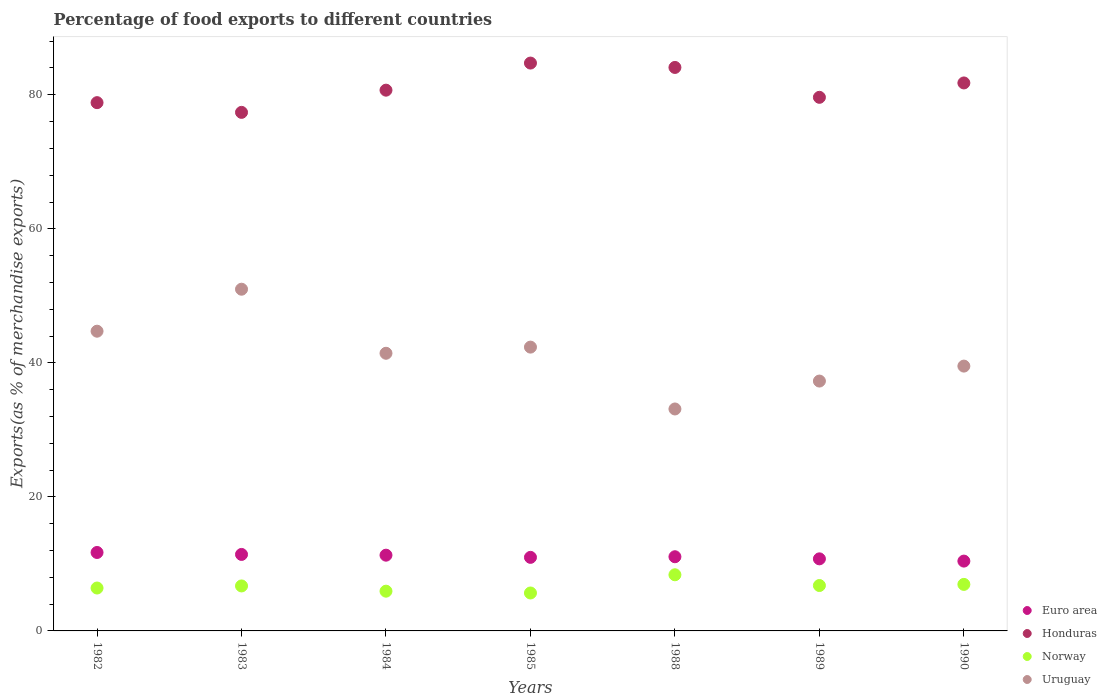What is the percentage of exports to different countries in Uruguay in 1990?
Provide a succinct answer. 39.52. Across all years, what is the maximum percentage of exports to different countries in Euro area?
Keep it short and to the point. 11.71. Across all years, what is the minimum percentage of exports to different countries in Norway?
Your answer should be very brief. 5.66. In which year was the percentage of exports to different countries in Euro area maximum?
Ensure brevity in your answer.  1982. In which year was the percentage of exports to different countries in Honduras minimum?
Your answer should be very brief. 1983. What is the total percentage of exports to different countries in Euro area in the graph?
Provide a succinct answer. 77.64. What is the difference between the percentage of exports to different countries in Uruguay in 1989 and that in 1990?
Offer a very short reply. -2.23. What is the difference between the percentage of exports to different countries in Norway in 1985 and the percentage of exports to different countries in Euro area in 1989?
Offer a terse response. -5.09. What is the average percentage of exports to different countries in Uruguay per year?
Your answer should be compact. 41.34. In the year 1988, what is the difference between the percentage of exports to different countries in Honduras and percentage of exports to different countries in Uruguay?
Ensure brevity in your answer.  50.96. In how many years, is the percentage of exports to different countries in Uruguay greater than 16 %?
Keep it short and to the point. 7. What is the ratio of the percentage of exports to different countries in Uruguay in 1985 to that in 1990?
Ensure brevity in your answer.  1.07. Is the percentage of exports to different countries in Uruguay in 1983 less than that in 1988?
Provide a succinct answer. No. What is the difference between the highest and the second highest percentage of exports to different countries in Euro area?
Give a very brief answer. 0.29. What is the difference between the highest and the lowest percentage of exports to different countries in Uruguay?
Make the answer very short. 17.87. Is the sum of the percentage of exports to different countries in Uruguay in 1988 and 1990 greater than the maximum percentage of exports to different countries in Honduras across all years?
Keep it short and to the point. No. Is it the case that in every year, the sum of the percentage of exports to different countries in Euro area and percentage of exports to different countries in Norway  is greater than the sum of percentage of exports to different countries in Honduras and percentage of exports to different countries in Uruguay?
Your answer should be very brief. No. Is it the case that in every year, the sum of the percentage of exports to different countries in Honduras and percentage of exports to different countries in Norway  is greater than the percentage of exports to different countries in Uruguay?
Your response must be concise. Yes. Does the graph contain grids?
Your answer should be compact. No. Where does the legend appear in the graph?
Your answer should be compact. Bottom right. How many legend labels are there?
Provide a short and direct response. 4. How are the legend labels stacked?
Provide a succinct answer. Vertical. What is the title of the graph?
Your answer should be compact. Percentage of food exports to different countries. What is the label or title of the Y-axis?
Your answer should be compact. Exports(as % of merchandise exports). What is the Exports(as % of merchandise exports) in Euro area in 1982?
Offer a terse response. 11.71. What is the Exports(as % of merchandise exports) of Honduras in 1982?
Provide a short and direct response. 78.83. What is the Exports(as % of merchandise exports) of Norway in 1982?
Offer a terse response. 6.4. What is the Exports(as % of merchandise exports) of Uruguay in 1982?
Give a very brief answer. 44.72. What is the Exports(as % of merchandise exports) in Euro area in 1983?
Your response must be concise. 11.41. What is the Exports(as % of merchandise exports) in Honduras in 1983?
Your answer should be compact. 77.38. What is the Exports(as % of merchandise exports) in Norway in 1983?
Keep it short and to the point. 6.71. What is the Exports(as % of merchandise exports) of Uruguay in 1983?
Make the answer very short. 50.99. What is the Exports(as % of merchandise exports) of Euro area in 1984?
Offer a terse response. 11.3. What is the Exports(as % of merchandise exports) in Honduras in 1984?
Keep it short and to the point. 80.69. What is the Exports(as % of merchandise exports) of Norway in 1984?
Provide a succinct answer. 5.93. What is the Exports(as % of merchandise exports) of Uruguay in 1984?
Offer a very short reply. 41.43. What is the Exports(as % of merchandise exports) of Euro area in 1985?
Offer a very short reply. 10.98. What is the Exports(as % of merchandise exports) of Honduras in 1985?
Give a very brief answer. 84.73. What is the Exports(as % of merchandise exports) of Norway in 1985?
Keep it short and to the point. 5.66. What is the Exports(as % of merchandise exports) of Uruguay in 1985?
Your response must be concise. 42.35. What is the Exports(as % of merchandise exports) of Euro area in 1988?
Provide a short and direct response. 11.07. What is the Exports(as % of merchandise exports) of Honduras in 1988?
Provide a short and direct response. 84.08. What is the Exports(as % of merchandise exports) in Norway in 1988?
Keep it short and to the point. 8.38. What is the Exports(as % of merchandise exports) of Uruguay in 1988?
Ensure brevity in your answer.  33.12. What is the Exports(as % of merchandise exports) of Euro area in 1989?
Offer a terse response. 10.75. What is the Exports(as % of merchandise exports) of Honduras in 1989?
Offer a very short reply. 79.62. What is the Exports(as % of merchandise exports) of Norway in 1989?
Provide a short and direct response. 6.77. What is the Exports(as % of merchandise exports) in Uruguay in 1989?
Keep it short and to the point. 37.28. What is the Exports(as % of merchandise exports) in Euro area in 1990?
Your response must be concise. 10.42. What is the Exports(as % of merchandise exports) in Honduras in 1990?
Your answer should be compact. 81.77. What is the Exports(as % of merchandise exports) in Norway in 1990?
Provide a succinct answer. 6.94. What is the Exports(as % of merchandise exports) of Uruguay in 1990?
Give a very brief answer. 39.52. Across all years, what is the maximum Exports(as % of merchandise exports) of Euro area?
Give a very brief answer. 11.71. Across all years, what is the maximum Exports(as % of merchandise exports) of Honduras?
Your response must be concise. 84.73. Across all years, what is the maximum Exports(as % of merchandise exports) in Norway?
Your answer should be very brief. 8.38. Across all years, what is the maximum Exports(as % of merchandise exports) of Uruguay?
Your response must be concise. 50.99. Across all years, what is the minimum Exports(as % of merchandise exports) of Euro area?
Offer a very short reply. 10.42. Across all years, what is the minimum Exports(as % of merchandise exports) in Honduras?
Ensure brevity in your answer.  77.38. Across all years, what is the minimum Exports(as % of merchandise exports) of Norway?
Give a very brief answer. 5.66. Across all years, what is the minimum Exports(as % of merchandise exports) of Uruguay?
Your answer should be compact. 33.12. What is the total Exports(as % of merchandise exports) of Euro area in the graph?
Offer a terse response. 77.64. What is the total Exports(as % of merchandise exports) in Honduras in the graph?
Keep it short and to the point. 567.09. What is the total Exports(as % of merchandise exports) in Norway in the graph?
Provide a succinct answer. 46.8. What is the total Exports(as % of merchandise exports) in Uruguay in the graph?
Ensure brevity in your answer.  289.41. What is the difference between the Exports(as % of merchandise exports) of Euro area in 1982 and that in 1983?
Offer a terse response. 0.29. What is the difference between the Exports(as % of merchandise exports) in Honduras in 1982 and that in 1983?
Keep it short and to the point. 1.45. What is the difference between the Exports(as % of merchandise exports) of Norway in 1982 and that in 1983?
Ensure brevity in your answer.  -0.31. What is the difference between the Exports(as % of merchandise exports) in Uruguay in 1982 and that in 1983?
Offer a very short reply. -6.26. What is the difference between the Exports(as % of merchandise exports) of Euro area in 1982 and that in 1984?
Keep it short and to the point. 0.4. What is the difference between the Exports(as % of merchandise exports) in Honduras in 1982 and that in 1984?
Your answer should be compact. -1.86. What is the difference between the Exports(as % of merchandise exports) in Norway in 1982 and that in 1984?
Provide a short and direct response. 0.47. What is the difference between the Exports(as % of merchandise exports) of Uruguay in 1982 and that in 1984?
Keep it short and to the point. 3.29. What is the difference between the Exports(as % of merchandise exports) in Euro area in 1982 and that in 1985?
Your answer should be very brief. 0.73. What is the difference between the Exports(as % of merchandise exports) of Honduras in 1982 and that in 1985?
Your answer should be very brief. -5.91. What is the difference between the Exports(as % of merchandise exports) in Norway in 1982 and that in 1985?
Offer a very short reply. 0.74. What is the difference between the Exports(as % of merchandise exports) of Uruguay in 1982 and that in 1985?
Offer a terse response. 2.38. What is the difference between the Exports(as % of merchandise exports) of Euro area in 1982 and that in 1988?
Provide a short and direct response. 0.64. What is the difference between the Exports(as % of merchandise exports) of Honduras in 1982 and that in 1988?
Your answer should be very brief. -5.25. What is the difference between the Exports(as % of merchandise exports) in Norway in 1982 and that in 1988?
Your response must be concise. -1.98. What is the difference between the Exports(as % of merchandise exports) in Uruguay in 1982 and that in 1988?
Provide a short and direct response. 11.6. What is the difference between the Exports(as % of merchandise exports) in Euro area in 1982 and that in 1989?
Your answer should be compact. 0.95. What is the difference between the Exports(as % of merchandise exports) in Honduras in 1982 and that in 1989?
Your answer should be very brief. -0.8. What is the difference between the Exports(as % of merchandise exports) of Norway in 1982 and that in 1989?
Offer a terse response. -0.37. What is the difference between the Exports(as % of merchandise exports) in Uruguay in 1982 and that in 1989?
Ensure brevity in your answer.  7.44. What is the difference between the Exports(as % of merchandise exports) of Euro area in 1982 and that in 1990?
Keep it short and to the point. 1.29. What is the difference between the Exports(as % of merchandise exports) in Honduras in 1982 and that in 1990?
Make the answer very short. -2.94. What is the difference between the Exports(as % of merchandise exports) of Norway in 1982 and that in 1990?
Offer a terse response. -0.54. What is the difference between the Exports(as % of merchandise exports) of Uruguay in 1982 and that in 1990?
Provide a succinct answer. 5.21. What is the difference between the Exports(as % of merchandise exports) of Euro area in 1983 and that in 1984?
Offer a very short reply. 0.11. What is the difference between the Exports(as % of merchandise exports) of Honduras in 1983 and that in 1984?
Give a very brief answer. -3.31. What is the difference between the Exports(as % of merchandise exports) in Norway in 1983 and that in 1984?
Provide a short and direct response. 0.78. What is the difference between the Exports(as % of merchandise exports) in Uruguay in 1983 and that in 1984?
Offer a terse response. 9.56. What is the difference between the Exports(as % of merchandise exports) of Euro area in 1983 and that in 1985?
Provide a succinct answer. 0.44. What is the difference between the Exports(as % of merchandise exports) of Honduras in 1983 and that in 1985?
Ensure brevity in your answer.  -7.36. What is the difference between the Exports(as % of merchandise exports) of Norway in 1983 and that in 1985?
Provide a short and direct response. 1.05. What is the difference between the Exports(as % of merchandise exports) in Uruguay in 1983 and that in 1985?
Your response must be concise. 8.64. What is the difference between the Exports(as % of merchandise exports) of Euro area in 1983 and that in 1988?
Your response must be concise. 0.34. What is the difference between the Exports(as % of merchandise exports) in Honduras in 1983 and that in 1988?
Offer a very short reply. -6.7. What is the difference between the Exports(as % of merchandise exports) in Norway in 1983 and that in 1988?
Make the answer very short. -1.67. What is the difference between the Exports(as % of merchandise exports) of Uruguay in 1983 and that in 1988?
Your answer should be very brief. 17.87. What is the difference between the Exports(as % of merchandise exports) in Euro area in 1983 and that in 1989?
Give a very brief answer. 0.66. What is the difference between the Exports(as % of merchandise exports) in Honduras in 1983 and that in 1989?
Give a very brief answer. -2.25. What is the difference between the Exports(as % of merchandise exports) of Norway in 1983 and that in 1989?
Offer a very short reply. -0.06. What is the difference between the Exports(as % of merchandise exports) in Uruguay in 1983 and that in 1989?
Offer a terse response. 13.71. What is the difference between the Exports(as % of merchandise exports) of Honduras in 1983 and that in 1990?
Offer a very short reply. -4.39. What is the difference between the Exports(as % of merchandise exports) of Norway in 1983 and that in 1990?
Give a very brief answer. -0.23. What is the difference between the Exports(as % of merchandise exports) of Uruguay in 1983 and that in 1990?
Keep it short and to the point. 11.47. What is the difference between the Exports(as % of merchandise exports) of Euro area in 1984 and that in 1985?
Give a very brief answer. 0.33. What is the difference between the Exports(as % of merchandise exports) of Honduras in 1984 and that in 1985?
Make the answer very short. -4.04. What is the difference between the Exports(as % of merchandise exports) in Norway in 1984 and that in 1985?
Your answer should be compact. 0.27. What is the difference between the Exports(as % of merchandise exports) of Uruguay in 1984 and that in 1985?
Offer a very short reply. -0.92. What is the difference between the Exports(as % of merchandise exports) in Euro area in 1984 and that in 1988?
Make the answer very short. 0.23. What is the difference between the Exports(as % of merchandise exports) of Honduras in 1984 and that in 1988?
Provide a succinct answer. -3.39. What is the difference between the Exports(as % of merchandise exports) in Norway in 1984 and that in 1988?
Your answer should be very brief. -2.45. What is the difference between the Exports(as % of merchandise exports) in Uruguay in 1984 and that in 1988?
Make the answer very short. 8.31. What is the difference between the Exports(as % of merchandise exports) in Euro area in 1984 and that in 1989?
Offer a very short reply. 0.55. What is the difference between the Exports(as % of merchandise exports) of Honduras in 1984 and that in 1989?
Make the answer very short. 1.07. What is the difference between the Exports(as % of merchandise exports) of Norway in 1984 and that in 1989?
Your answer should be compact. -0.84. What is the difference between the Exports(as % of merchandise exports) of Uruguay in 1984 and that in 1989?
Your answer should be compact. 4.15. What is the difference between the Exports(as % of merchandise exports) in Euro area in 1984 and that in 1990?
Offer a very short reply. 0.88. What is the difference between the Exports(as % of merchandise exports) of Honduras in 1984 and that in 1990?
Provide a succinct answer. -1.08. What is the difference between the Exports(as % of merchandise exports) of Norway in 1984 and that in 1990?
Keep it short and to the point. -1.01. What is the difference between the Exports(as % of merchandise exports) of Uruguay in 1984 and that in 1990?
Keep it short and to the point. 1.91. What is the difference between the Exports(as % of merchandise exports) of Euro area in 1985 and that in 1988?
Your answer should be very brief. -0.09. What is the difference between the Exports(as % of merchandise exports) of Honduras in 1985 and that in 1988?
Offer a terse response. 0.65. What is the difference between the Exports(as % of merchandise exports) in Norway in 1985 and that in 1988?
Make the answer very short. -2.72. What is the difference between the Exports(as % of merchandise exports) in Uruguay in 1985 and that in 1988?
Offer a terse response. 9.23. What is the difference between the Exports(as % of merchandise exports) of Euro area in 1985 and that in 1989?
Make the answer very short. 0.22. What is the difference between the Exports(as % of merchandise exports) of Honduras in 1985 and that in 1989?
Your response must be concise. 5.11. What is the difference between the Exports(as % of merchandise exports) of Norway in 1985 and that in 1989?
Your answer should be compact. -1.11. What is the difference between the Exports(as % of merchandise exports) of Uruguay in 1985 and that in 1989?
Ensure brevity in your answer.  5.07. What is the difference between the Exports(as % of merchandise exports) in Euro area in 1985 and that in 1990?
Offer a terse response. 0.56. What is the difference between the Exports(as % of merchandise exports) of Honduras in 1985 and that in 1990?
Your answer should be very brief. 2.97. What is the difference between the Exports(as % of merchandise exports) in Norway in 1985 and that in 1990?
Your response must be concise. -1.28. What is the difference between the Exports(as % of merchandise exports) in Uruguay in 1985 and that in 1990?
Make the answer very short. 2.83. What is the difference between the Exports(as % of merchandise exports) of Euro area in 1988 and that in 1989?
Keep it short and to the point. 0.31. What is the difference between the Exports(as % of merchandise exports) of Honduras in 1988 and that in 1989?
Ensure brevity in your answer.  4.46. What is the difference between the Exports(as % of merchandise exports) of Norway in 1988 and that in 1989?
Your answer should be compact. 1.6. What is the difference between the Exports(as % of merchandise exports) in Uruguay in 1988 and that in 1989?
Your answer should be very brief. -4.16. What is the difference between the Exports(as % of merchandise exports) of Euro area in 1988 and that in 1990?
Offer a very short reply. 0.65. What is the difference between the Exports(as % of merchandise exports) of Honduras in 1988 and that in 1990?
Provide a short and direct response. 2.31. What is the difference between the Exports(as % of merchandise exports) of Norway in 1988 and that in 1990?
Give a very brief answer. 1.44. What is the difference between the Exports(as % of merchandise exports) in Uruguay in 1988 and that in 1990?
Ensure brevity in your answer.  -6.4. What is the difference between the Exports(as % of merchandise exports) of Euro area in 1989 and that in 1990?
Ensure brevity in your answer.  0.34. What is the difference between the Exports(as % of merchandise exports) of Honduras in 1989 and that in 1990?
Ensure brevity in your answer.  -2.15. What is the difference between the Exports(as % of merchandise exports) of Norway in 1989 and that in 1990?
Offer a terse response. -0.17. What is the difference between the Exports(as % of merchandise exports) in Uruguay in 1989 and that in 1990?
Provide a succinct answer. -2.23. What is the difference between the Exports(as % of merchandise exports) in Euro area in 1982 and the Exports(as % of merchandise exports) in Honduras in 1983?
Make the answer very short. -65.67. What is the difference between the Exports(as % of merchandise exports) of Euro area in 1982 and the Exports(as % of merchandise exports) of Norway in 1983?
Offer a very short reply. 4.99. What is the difference between the Exports(as % of merchandise exports) in Euro area in 1982 and the Exports(as % of merchandise exports) in Uruguay in 1983?
Ensure brevity in your answer.  -39.28. What is the difference between the Exports(as % of merchandise exports) of Honduras in 1982 and the Exports(as % of merchandise exports) of Norway in 1983?
Ensure brevity in your answer.  72.11. What is the difference between the Exports(as % of merchandise exports) of Honduras in 1982 and the Exports(as % of merchandise exports) of Uruguay in 1983?
Provide a succinct answer. 27.84. What is the difference between the Exports(as % of merchandise exports) in Norway in 1982 and the Exports(as % of merchandise exports) in Uruguay in 1983?
Your answer should be compact. -44.59. What is the difference between the Exports(as % of merchandise exports) in Euro area in 1982 and the Exports(as % of merchandise exports) in Honduras in 1984?
Offer a terse response. -68.98. What is the difference between the Exports(as % of merchandise exports) in Euro area in 1982 and the Exports(as % of merchandise exports) in Norway in 1984?
Give a very brief answer. 5.77. What is the difference between the Exports(as % of merchandise exports) of Euro area in 1982 and the Exports(as % of merchandise exports) of Uruguay in 1984?
Keep it short and to the point. -29.73. What is the difference between the Exports(as % of merchandise exports) of Honduras in 1982 and the Exports(as % of merchandise exports) of Norway in 1984?
Provide a succinct answer. 72.9. What is the difference between the Exports(as % of merchandise exports) of Honduras in 1982 and the Exports(as % of merchandise exports) of Uruguay in 1984?
Provide a succinct answer. 37.4. What is the difference between the Exports(as % of merchandise exports) of Norway in 1982 and the Exports(as % of merchandise exports) of Uruguay in 1984?
Your answer should be very brief. -35.03. What is the difference between the Exports(as % of merchandise exports) of Euro area in 1982 and the Exports(as % of merchandise exports) of Honduras in 1985?
Offer a terse response. -73.03. What is the difference between the Exports(as % of merchandise exports) in Euro area in 1982 and the Exports(as % of merchandise exports) in Norway in 1985?
Make the answer very short. 6.04. What is the difference between the Exports(as % of merchandise exports) of Euro area in 1982 and the Exports(as % of merchandise exports) of Uruguay in 1985?
Make the answer very short. -30.64. What is the difference between the Exports(as % of merchandise exports) of Honduras in 1982 and the Exports(as % of merchandise exports) of Norway in 1985?
Provide a short and direct response. 73.17. What is the difference between the Exports(as % of merchandise exports) in Honduras in 1982 and the Exports(as % of merchandise exports) in Uruguay in 1985?
Give a very brief answer. 36.48. What is the difference between the Exports(as % of merchandise exports) of Norway in 1982 and the Exports(as % of merchandise exports) of Uruguay in 1985?
Your answer should be very brief. -35.95. What is the difference between the Exports(as % of merchandise exports) of Euro area in 1982 and the Exports(as % of merchandise exports) of Honduras in 1988?
Your answer should be very brief. -72.37. What is the difference between the Exports(as % of merchandise exports) in Euro area in 1982 and the Exports(as % of merchandise exports) in Norway in 1988?
Your response must be concise. 3.33. What is the difference between the Exports(as % of merchandise exports) of Euro area in 1982 and the Exports(as % of merchandise exports) of Uruguay in 1988?
Ensure brevity in your answer.  -21.41. What is the difference between the Exports(as % of merchandise exports) in Honduras in 1982 and the Exports(as % of merchandise exports) in Norway in 1988?
Offer a very short reply. 70.45. What is the difference between the Exports(as % of merchandise exports) in Honduras in 1982 and the Exports(as % of merchandise exports) in Uruguay in 1988?
Offer a very short reply. 45.71. What is the difference between the Exports(as % of merchandise exports) of Norway in 1982 and the Exports(as % of merchandise exports) of Uruguay in 1988?
Keep it short and to the point. -26.72. What is the difference between the Exports(as % of merchandise exports) in Euro area in 1982 and the Exports(as % of merchandise exports) in Honduras in 1989?
Your answer should be very brief. -67.92. What is the difference between the Exports(as % of merchandise exports) in Euro area in 1982 and the Exports(as % of merchandise exports) in Norway in 1989?
Your answer should be very brief. 4.93. What is the difference between the Exports(as % of merchandise exports) of Euro area in 1982 and the Exports(as % of merchandise exports) of Uruguay in 1989?
Your answer should be very brief. -25.58. What is the difference between the Exports(as % of merchandise exports) of Honduras in 1982 and the Exports(as % of merchandise exports) of Norway in 1989?
Make the answer very short. 72.05. What is the difference between the Exports(as % of merchandise exports) in Honduras in 1982 and the Exports(as % of merchandise exports) in Uruguay in 1989?
Your response must be concise. 41.54. What is the difference between the Exports(as % of merchandise exports) of Norway in 1982 and the Exports(as % of merchandise exports) of Uruguay in 1989?
Your answer should be very brief. -30.88. What is the difference between the Exports(as % of merchandise exports) in Euro area in 1982 and the Exports(as % of merchandise exports) in Honduras in 1990?
Provide a succinct answer. -70.06. What is the difference between the Exports(as % of merchandise exports) in Euro area in 1982 and the Exports(as % of merchandise exports) in Norway in 1990?
Your response must be concise. 4.76. What is the difference between the Exports(as % of merchandise exports) of Euro area in 1982 and the Exports(as % of merchandise exports) of Uruguay in 1990?
Give a very brief answer. -27.81. What is the difference between the Exports(as % of merchandise exports) in Honduras in 1982 and the Exports(as % of merchandise exports) in Norway in 1990?
Give a very brief answer. 71.88. What is the difference between the Exports(as % of merchandise exports) of Honduras in 1982 and the Exports(as % of merchandise exports) of Uruguay in 1990?
Your answer should be very brief. 39.31. What is the difference between the Exports(as % of merchandise exports) in Norway in 1982 and the Exports(as % of merchandise exports) in Uruguay in 1990?
Your answer should be compact. -33.12. What is the difference between the Exports(as % of merchandise exports) of Euro area in 1983 and the Exports(as % of merchandise exports) of Honduras in 1984?
Make the answer very short. -69.28. What is the difference between the Exports(as % of merchandise exports) of Euro area in 1983 and the Exports(as % of merchandise exports) of Norway in 1984?
Offer a very short reply. 5.48. What is the difference between the Exports(as % of merchandise exports) of Euro area in 1983 and the Exports(as % of merchandise exports) of Uruguay in 1984?
Provide a succinct answer. -30.02. What is the difference between the Exports(as % of merchandise exports) of Honduras in 1983 and the Exports(as % of merchandise exports) of Norway in 1984?
Make the answer very short. 71.45. What is the difference between the Exports(as % of merchandise exports) in Honduras in 1983 and the Exports(as % of merchandise exports) in Uruguay in 1984?
Your answer should be very brief. 35.95. What is the difference between the Exports(as % of merchandise exports) in Norway in 1983 and the Exports(as % of merchandise exports) in Uruguay in 1984?
Your answer should be compact. -34.72. What is the difference between the Exports(as % of merchandise exports) of Euro area in 1983 and the Exports(as % of merchandise exports) of Honduras in 1985?
Ensure brevity in your answer.  -73.32. What is the difference between the Exports(as % of merchandise exports) of Euro area in 1983 and the Exports(as % of merchandise exports) of Norway in 1985?
Offer a very short reply. 5.75. What is the difference between the Exports(as % of merchandise exports) in Euro area in 1983 and the Exports(as % of merchandise exports) in Uruguay in 1985?
Your answer should be very brief. -30.93. What is the difference between the Exports(as % of merchandise exports) in Honduras in 1983 and the Exports(as % of merchandise exports) in Norway in 1985?
Provide a short and direct response. 71.72. What is the difference between the Exports(as % of merchandise exports) in Honduras in 1983 and the Exports(as % of merchandise exports) in Uruguay in 1985?
Offer a terse response. 35.03. What is the difference between the Exports(as % of merchandise exports) of Norway in 1983 and the Exports(as % of merchandise exports) of Uruguay in 1985?
Offer a terse response. -35.64. What is the difference between the Exports(as % of merchandise exports) of Euro area in 1983 and the Exports(as % of merchandise exports) of Honduras in 1988?
Provide a short and direct response. -72.67. What is the difference between the Exports(as % of merchandise exports) in Euro area in 1983 and the Exports(as % of merchandise exports) in Norway in 1988?
Your response must be concise. 3.04. What is the difference between the Exports(as % of merchandise exports) in Euro area in 1983 and the Exports(as % of merchandise exports) in Uruguay in 1988?
Provide a short and direct response. -21.71. What is the difference between the Exports(as % of merchandise exports) of Honduras in 1983 and the Exports(as % of merchandise exports) of Norway in 1988?
Offer a terse response. 69. What is the difference between the Exports(as % of merchandise exports) of Honduras in 1983 and the Exports(as % of merchandise exports) of Uruguay in 1988?
Your response must be concise. 44.26. What is the difference between the Exports(as % of merchandise exports) of Norway in 1983 and the Exports(as % of merchandise exports) of Uruguay in 1988?
Offer a terse response. -26.41. What is the difference between the Exports(as % of merchandise exports) of Euro area in 1983 and the Exports(as % of merchandise exports) of Honduras in 1989?
Offer a very short reply. -68.21. What is the difference between the Exports(as % of merchandise exports) in Euro area in 1983 and the Exports(as % of merchandise exports) in Norway in 1989?
Give a very brief answer. 4.64. What is the difference between the Exports(as % of merchandise exports) of Euro area in 1983 and the Exports(as % of merchandise exports) of Uruguay in 1989?
Offer a very short reply. -25.87. What is the difference between the Exports(as % of merchandise exports) of Honduras in 1983 and the Exports(as % of merchandise exports) of Norway in 1989?
Provide a short and direct response. 70.6. What is the difference between the Exports(as % of merchandise exports) of Honduras in 1983 and the Exports(as % of merchandise exports) of Uruguay in 1989?
Your answer should be very brief. 40.09. What is the difference between the Exports(as % of merchandise exports) of Norway in 1983 and the Exports(as % of merchandise exports) of Uruguay in 1989?
Offer a terse response. -30.57. What is the difference between the Exports(as % of merchandise exports) of Euro area in 1983 and the Exports(as % of merchandise exports) of Honduras in 1990?
Offer a terse response. -70.35. What is the difference between the Exports(as % of merchandise exports) of Euro area in 1983 and the Exports(as % of merchandise exports) of Norway in 1990?
Provide a short and direct response. 4.47. What is the difference between the Exports(as % of merchandise exports) in Euro area in 1983 and the Exports(as % of merchandise exports) in Uruguay in 1990?
Your answer should be very brief. -28.1. What is the difference between the Exports(as % of merchandise exports) in Honduras in 1983 and the Exports(as % of merchandise exports) in Norway in 1990?
Keep it short and to the point. 70.43. What is the difference between the Exports(as % of merchandise exports) in Honduras in 1983 and the Exports(as % of merchandise exports) in Uruguay in 1990?
Ensure brevity in your answer.  37.86. What is the difference between the Exports(as % of merchandise exports) of Norway in 1983 and the Exports(as % of merchandise exports) of Uruguay in 1990?
Ensure brevity in your answer.  -32.8. What is the difference between the Exports(as % of merchandise exports) in Euro area in 1984 and the Exports(as % of merchandise exports) in Honduras in 1985?
Your answer should be compact. -73.43. What is the difference between the Exports(as % of merchandise exports) of Euro area in 1984 and the Exports(as % of merchandise exports) of Norway in 1985?
Your answer should be compact. 5.64. What is the difference between the Exports(as % of merchandise exports) in Euro area in 1984 and the Exports(as % of merchandise exports) in Uruguay in 1985?
Your answer should be very brief. -31.05. What is the difference between the Exports(as % of merchandise exports) in Honduras in 1984 and the Exports(as % of merchandise exports) in Norway in 1985?
Provide a succinct answer. 75.03. What is the difference between the Exports(as % of merchandise exports) of Honduras in 1984 and the Exports(as % of merchandise exports) of Uruguay in 1985?
Make the answer very short. 38.34. What is the difference between the Exports(as % of merchandise exports) of Norway in 1984 and the Exports(as % of merchandise exports) of Uruguay in 1985?
Make the answer very short. -36.42. What is the difference between the Exports(as % of merchandise exports) of Euro area in 1984 and the Exports(as % of merchandise exports) of Honduras in 1988?
Keep it short and to the point. -72.78. What is the difference between the Exports(as % of merchandise exports) of Euro area in 1984 and the Exports(as % of merchandise exports) of Norway in 1988?
Offer a terse response. 2.92. What is the difference between the Exports(as % of merchandise exports) of Euro area in 1984 and the Exports(as % of merchandise exports) of Uruguay in 1988?
Ensure brevity in your answer.  -21.82. What is the difference between the Exports(as % of merchandise exports) of Honduras in 1984 and the Exports(as % of merchandise exports) of Norway in 1988?
Your answer should be compact. 72.31. What is the difference between the Exports(as % of merchandise exports) of Honduras in 1984 and the Exports(as % of merchandise exports) of Uruguay in 1988?
Your answer should be compact. 47.57. What is the difference between the Exports(as % of merchandise exports) of Norway in 1984 and the Exports(as % of merchandise exports) of Uruguay in 1988?
Give a very brief answer. -27.19. What is the difference between the Exports(as % of merchandise exports) of Euro area in 1984 and the Exports(as % of merchandise exports) of Honduras in 1989?
Provide a succinct answer. -68.32. What is the difference between the Exports(as % of merchandise exports) in Euro area in 1984 and the Exports(as % of merchandise exports) in Norway in 1989?
Make the answer very short. 4.53. What is the difference between the Exports(as % of merchandise exports) in Euro area in 1984 and the Exports(as % of merchandise exports) in Uruguay in 1989?
Your answer should be compact. -25.98. What is the difference between the Exports(as % of merchandise exports) in Honduras in 1984 and the Exports(as % of merchandise exports) in Norway in 1989?
Keep it short and to the point. 73.91. What is the difference between the Exports(as % of merchandise exports) in Honduras in 1984 and the Exports(as % of merchandise exports) in Uruguay in 1989?
Ensure brevity in your answer.  43.41. What is the difference between the Exports(as % of merchandise exports) of Norway in 1984 and the Exports(as % of merchandise exports) of Uruguay in 1989?
Offer a very short reply. -31.35. What is the difference between the Exports(as % of merchandise exports) of Euro area in 1984 and the Exports(as % of merchandise exports) of Honduras in 1990?
Offer a very short reply. -70.46. What is the difference between the Exports(as % of merchandise exports) of Euro area in 1984 and the Exports(as % of merchandise exports) of Norway in 1990?
Ensure brevity in your answer.  4.36. What is the difference between the Exports(as % of merchandise exports) of Euro area in 1984 and the Exports(as % of merchandise exports) of Uruguay in 1990?
Offer a very short reply. -28.21. What is the difference between the Exports(as % of merchandise exports) in Honduras in 1984 and the Exports(as % of merchandise exports) in Norway in 1990?
Keep it short and to the point. 73.75. What is the difference between the Exports(as % of merchandise exports) in Honduras in 1984 and the Exports(as % of merchandise exports) in Uruguay in 1990?
Your answer should be very brief. 41.17. What is the difference between the Exports(as % of merchandise exports) of Norway in 1984 and the Exports(as % of merchandise exports) of Uruguay in 1990?
Your answer should be very brief. -33.59. What is the difference between the Exports(as % of merchandise exports) of Euro area in 1985 and the Exports(as % of merchandise exports) of Honduras in 1988?
Make the answer very short. -73.1. What is the difference between the Exports(as % of merchandise exports) of Euro area in 1985 and the Exports(as % of merchandise exports) of Norway in 1988?
Provide a succinct answer. 2.6. What is the difference between the Exports(as % of merchandise exports) in Euro area in 1985 and the Exports(as % of merchandise exports) in Uruguay in 1988?
Make the answer very short. -22.14. What is the difference between the Exports(as % of merchandise exports) in Honduras in 1985 and the Exports(as % of merchandise exports) in Norway in 1988?
Your answer should be compact. 76.35. What is the difference between the Exports(as % of merchandise exports) in Honduras in 1985 and the Exports(as % of merchandise exports) in Uruguay in 1988?
Offer a very short reply. 51.61. What is the difference between the Exports(as % of merchandise exports) of Norway in 1985 and the Exports(as % of merchandise exports) of Uruguay in 1988?
Your response must be concise. -27.46. What is the difference between the Exports(as % of merchandise exports) in Euro area in 1985 and the Exports(as % of merchandise exports) in Honduras in 1989?
Offer a terse response. -68.64. What is the difference between the Exports(as % of merchandise exports) in Euro area in 1985 and the Exports(as % of merchandise exports) in Norway in 1989?
Your answer should be very brief. 4.2. What is the difference between the Exports(as % of merchandise exports) of Euro area in 1985 and the Exports(as % of merchandise exports) of Uruguay in 1989?
Your response must be concise. -26.31. What is the difference between the Exports(as % of merchandise exports) of Honduras in 1985 and the Exports(as % of merchandise exports) of Norway in 1989?
Keep it short and to the point. 77.96. What is the difference between the Exports(as % of merchandise exports) of Honduras in 1985 and the Exports(as % of merchandise exports) of Uruguay in 1989?
Your answer should be compact. 47.45. What is the difference between the Exports(as % of merchandise exports) of Norway in 1985 and the Exports(as % of merchandise exports) of Uruguay in 1989?
Ensure brevity in your answer.  -31.62. What is the difference between the Exports(as % of merchandise exports) in Euro area in 1985 and the Exports(as % of merchandise exports) in Honduras in 1990?
Make the answer very short. -70.79. What is the difference between the Exports(as % of merchandise exports) in Euro area in 1985 and the Exports(as % of merchandise exports) in Norway in 1990?
Offer a very short reply. 4.03. What is the difference between the Exports(as % of merchandise exports) in Euro area in 1985 and the Exports(as % of merchandise exports) in Uruguay in 1990?
Give a very brief answer. -28.54. What is the difference between the Exports(as % of merchandise exports) of Honduras in 1985 and the Exports(as % of merchandise exports) of Norway in 1990?
Offer a very short reply. 77.79. What is the difference between the Exports(as % of merchandise exports) in Honduras in 1985 and the Exports(as % of merchandise exports) in Uruguay in 1990?
Keep it short and to the point. 45.22. What is the difference between the Exports(as % of merchandise exports) in Norway in 1985 and the Exports(as % of merchandise exports) in Uruguay in 1990?
Provide a short and direct response. -33.86. What is the difference between the Exports(as % of merchandise exports) in Euro area in 1988 and the Exports(as % of merchandise exports) in Honduras in 1989?
Your answer should be very brief. -68.55. What is the difference between the Exports(as % of merchandise exports) in Euro area in 1988 and the Exports(as % of merchandise exports) in Norway in 1989?
Ensure brevity in your answer.  4.29. What is the difference between the Exports(as % of merchandise exports) in Euro area in 1988 and the Exports(as % of merchandise exports) in Uruguay in 1989?
Your response must be concise. -26.21. What is the difference between the Exports(as % of merchandise exports) of Honduras in 1988 and the Exports(as % of merchandise exports) of Norway in 1989?
Ensure brevity in your answer.  77.3. What is the difference between the Exports(as % of merchandise exports) of Honduras in 1988 and the Exports(as % of merchandise exports) of Uruguay in 1989?
Give a very brief answer. 46.8. What is the difference between the Exports(as % of merchandise exports) in Norway in 1988 and the Exports(as % of merchandise exports) in Uruguay in 1989?
Provide a short and direct response. -28.91. What is the difference between the Exports(as % of merchandise exports) in Euro area in 1988 and the Exports(as % of merchandise exports) in Honduras in 1990?
Provide a short and direct response. -70.7. What is the difference between the Exports(as % of merchandise exports) of Euro area in 1988 and the Exports(as % of merchandise exports) of Norway in 1990?
Give a very brief answer. 4.13. What is the difference between the Exports(as % of merchandise exports) of Euro area in 1988 and the Exports(as % of merchandise exports) of Uruguay in 1990?
Give a very brief answer. -28.45. What is the difference between the Exports(as % of merchandise exports) of Honduras in 1988 and the Exports(as % of merchandise exports) of Norway in 1990?
Your answer should be very brief. 77.14. What is the difference between the Exports(as % of merchandise exports) of Honduras in 1988 and the Exports(as % of merchandise exports) of Uruguay in 1990?
Offer a very short reply. 44.56. What is the difference between the Exports(as % of merchandise exports) of Norway in 1988 and the Exports(as % of merchandise exports) of Uruguay in 1990?
Ensure brevity in your answer.  -31.14. What is the difference between the Exports(as % of merchandise exports) of Euro area in 1989 and the Exports(as % of merchandise exports) of Honduras in 1990?
Offer a very short reply. -71.01. What is the difference between the Exports(as % of merchandise exports) in Euro area in 1989 and the Exports(as % of merchandise exports) in Norway in 1990?
Your answer should be very brief. 3.81. What is the difference between the Exports(as % of merchandise exports) of Euro area in 1989 and the Exports(as % of merchandise exports) of Uruguay in 1990?
Ensure brevity in your answer.  -28.76. What is the difference between the Exports(as % of merchandise exports) in Honduras in 1989 and the Exports(as % of merchandise exports) in Norway in 1990?
Keep it short and to the point. 72.68. What is the difference between the Exports(as % of merchandise exports) in Honduras in 1989 and the Exports(as % of merchandise exports) in Uruguay in 1990?
Make the answer very short. 40.11. What is the difference between the Exports(as % of merchandise exports) in Norway in 1989 and the Exports(as % of merchandise exports) in Uruguay in 1990?
Your response must be concise. -32.74. What is the average Exports(as % of merchandise exports) in Euro area per year?
Your response must be concise. 11.09. What is the average Exports(as % of merchandise exports) in Honduras per year?
Your answer should be compact. 81.01. What is the average Exports(as % of merchandise exports) of Norway per year?
Your answer should be very brief. 6.69. What is the average Exports(as % of merchandise exports) of Uruguay per year?
Your answer should be very brief. 41.34. In the year 1982, what is the difference between the Exports(as % of merchandise exports) of Euro area and Exports(as % of merchandise exports) of Honduras?
Offer a very short reply. -67.12. In the year 1982, what is the difference between the Exports(as % of merchandise exports) of Euro area and Exports(as % of merchandise exports) of Norway?
Offer a very short reply. 5.3. In the year 1982, what is the difference between the Exports(as % of merchandise exports) of Euro area and Exports(as % of merchandise exports) of Uruguay?
Provide a short and direct response. -33.02. In the year 1982, what is the difference between the Exports(as % of merchandise exports) in Honduras and Exports(as % of merchandise exports) in Norway?
Keep it short and to the point. 72.43. In the year 1982, what is the difference between the Exports(as % of merchandise exports) in Honduras and Exports(as % of merchandise exports) in Uruguay?
Your response must be concise. 34.1. In the year 1982, what is the difference between the Exports(as % of merchandise exports) in Norway and Exports(as % of merchandise exports) in Uruguay?
Provide a short and direct response. -38.32. In the year 1983, what is the difference between the Exports(as % of merchandise exports) in Euro area and Exports(as % of merchandise exports) in Honduras?
Provide a succinct answer. -65.96. In the year 1983, what is the difference between the Exports(as % of merchandise exports) in Euro area and Exports(as % of merchandise exports) in Norway?
Provide a short and direct response. 4.7. In the year 1983, what is the difference between the Exports(as % of merchandise exports) in Euro area and Exports(as % of merchandise exports) in Uruguay?
Ensure brevity in your answer.  -39.58. In the year 1983, what is the difference between the Exports(as % of merchandise exports) of Honduras and Exports(as % of merchandise exports) of Norway?
Offer a very short reply. 70.66. In the year 1983, what is the difference between the Exports(as % of merchandise exports) of Honduras and Exports(as % of merchandise exports) of Uruguay?
Your answer should be very brief. 26.39. In the year 1983, what is the difference between the Exports(as % of merchandise exports) in Norway and Exports(as % of merchandise exports) in Uruguay?
Offer a terse response. -44.28. In the year 1984, what is the difference between the Exports(as % of merchandise exports) of Euro area and Exports(as % of merchandise exports) of Honduras?
Offer a terse response. -69.39. In the year 1984, what is the difference between the Exports(as % of merchandise exports) of Euro area and Exports(as % of merchandise exports) of Norway?
Provide a succinct answer. 5.37. In the year 1984, what is the difference between the Exports(as % of merchandise exports) in Euro area and Exports(as % of merchandise exports) in Uruguay?
Your answer should be very brief. -30.13. In the year 1984, what is the difference between the Exports(as % of merchandise exports) of Honduras and Exports(as % of merchandise exports) of Norway?
Keep it short and to the point. 74.76. In the year 1984, what is the difference between the Exports(as % of merchandise exports) of Honduras and Exports(as % of merchandise exports) of Uruguay?
Offer a very short reply. 39.26. In the year 1984, what is the difference between the Exports(as % of merchandise exports) of Norway and Exports(as % of merchandise exports) of Uruguay?
Keep it short and to the point. -35.5. In the year 1985, what is the difference between the Exports(as % of merchandise exports) of Euro area and Exports(as % of merchandise exports) of Honduras?
Your answer should be very brief. -73.76. In the year 1985, what is the difference between the Exports(as % of merchandise exports) in Euro area and Exports(as % of merchandise exports) in Norway?
Keep it short and to the point. 5.32. In the year 1985, what is the difference between the Exports(as % of merchandise exports) of Euro area and Exports(as % of merchandise exports) of Uruguay?
Offer a very short reply. -31.37. In the year 1985, what is the difference between the Exports(as % of merchandise exports) of Honduras and Exports(as % of merchandise exports) of Norway?
Provide a short and direct response. 79.07. In the year 1985, what is the difference between the Exports(as % of merchandise exports) of Honduras and Exports(as % of merchandise exports) of Uruguay?
Your answer should be compact. 42.38. In the year 1985, what is the difference between the Exports(as % of merchandise exports) in Norway and Exports(as % of merchandise exports) in Uruguay?
Offer a terse response. -36.69. In the year 1988, what is the difference between the Exports(as % of merchandise exports) of Euro area and Exports(as % of merchandise exports) of Honduras?
Offer a terse response. -73.01. In the year 1988, what is the difference between the Exports(as % of merchandise exports) of Euro area and Exports(as % of merchandise exports) of Norway?
Your answer should be very brief. 2.69. In the year 1988, what is the difference between the Exports(as % of merchandise exports) in Euro area and Exports(as % of merchandise exports) in Uruguay?
Provide a succinct answer. -22.05. In the year 1988, what is the difference between the Exports(as % of merchandise exports) of Honduras and Exports(as % of merchandise exports) of Norway?
Offer a terse response. 75.7. In the year 1988, what is the difference between the Exports(as % of merchandise exports) in Honduras and Exports(as % of merchandise exports) in Uruguay?
Give a very brief answer. 50.96. In the year 1988, what is the difference between the Exports(as % of merchandise exports) in Norway and Exports(as % of merchandise exports) in Uruguay?
Your answer should be very brief. -24.74. In the year 1989, what is the difference between the Exports(as % of merchandise exports) of Euro area and Exports(as % of merchandise exports) of Honduras?
Offer a very short reply. -68.87. In the year 1989, what is the difference between the Exports(as % of merchandise exports) in Euro area and Exports(as % of merchandise exports) in Norway?
Provide a short and direct response. 3.98. In the year 1989, what is the difference between the Exports(as % of merchandise exports) of Euro area and Exports(as % of merchandise exports) of Uruguay?
Ensure brevity in your answer.  -26.53. In the year 1989, what is the difference between the Exports(as % of merchandise exports) in Honduras and Exports(as % of merchandise exports) in Norway?
Ensure brevity in your answer.  72.85. In the year 1989, what is the difference between the Exports(as % of merchandise exports) of Honduras and Exports(as % of merchandise exports) of Uruguay?
Ensure brevity in your answer.  42.34. In the year 1989, what is the difference between the Exports(as % of merchandise exports) of Norway and Exports(as % of merchandise exports) of Uruguay?
Give a very brief answer. -30.51. In the year 1990, what is the difference between the Exports(as % of merchandise exports) in Euro area and Exports(as % of merchandise exports) in Honduras?
Provide a succinct answer. -71.35. In the year 1990, what is the difference between the Exports(as % of merchandise exports) in Euro area and Exports(as % of merchandise exports) in Norway?
Your answer should be very brief. 3.48. In the year 1990, what is the difference between the Exports(as % of merchandise exports) of Euro area and Exports(as % of merchandise exports) of Uruguay?
Your response must be concise. -29.1. In the year 1990, what is the difference between the Exports(as % of merchandise exports) in Honduras and Exports(as % of merchandise exports) in Norway?
Your answer should be compact. 74.82. In the year 1990, what is the difference between the Exports(as % of merchandise exports) of Honduras and Exports(as % of merchandise exports) of Uruguay?
Your response must be concise. 42.25. In the year 1990, what is the difference between the Exports(as % of merchandise exports) in Norway and Exports(as % of merchandise exports) in Uruguay?
Offer a terse response. -32.57. What is the ratio of the Exports(as % of merchandise exports) of Euro area in 1982 to that in 1983?
Provide a short and direct response. 1.03. What is the ratio of the Exports(as % of merchandise exports) of Honduras in 1982 to that in 1983?
Offer a terse response. 1.02. What is the ratio of the Exports(as % of merchandise exports) in Norway in 1982 to that in 1983?
Offer a very short reply. 0.95. What is the ratio of the Exports(as % of merchandise exports) of Uruguay in 1982 to that in 1983?
Make the answer very short. 0.88. What is the ratio of the Exports(as % of merchandise exports) in Euro area in 1982 to that in 1984?
Your response must be concise. 1.04. What is the ratio of the Exports(as % of merchandise exports) of Honduras in 1982 to that in 1984?
Keep it short and to the point. 0.98. What is the ratio of the Exports(as % of merchandise exports) in Norway in 1982 to that in 1984?
Ensure brevity in your answer.  1.08. What is the ratio of the Exports(as % of merchandise exports) of Uruguay in 1982 to that in 1984?
Ensure brevity in your answer.  1.08. What is the ratio of the Exports(as % of merchandise exports) of Euro area in 1982 to that in 1985?
Offer a terse response. 1.07. What is the ratio of the Exports(as % of merchandise exports) in Honduras in 1982 to that in 1985?
Make the answer very short. 0.93. What is the ratio of the Exports(as % of merchandise exports) in Norway in 1982 to that in 1985?
Provide a succinct answer. 1.13. What is the ratio of the Exports(as % of merchandise exports) in Uruguay in 1982 to that in 1985?
Offer a very short reply. 1.06. What is the ratio of the Exports(as % of merchandise exports) in Euro area in 1982 to that in 1988?
Ensure brevity in your answer.  1.06. What is the ratio of the Exports(as % of merchandise exports) of Honduras in 1982 to that in 1988?
Provide a succinct answer. 0.94. What is the ratio of the Exports(as % of merchandise exports) of Norway in 1982 to that in 1988?
Make the answer very short. 0.76. What is the ratio of the Exports(as % of merchandise exports) in Uruguay in 1982 to that in 1988?
Provide a succinct answer. 1.35. What is the ratio of the Exports(as % of merchandise exports) of Euro area in 1982 to that in 1989?
Keep it short and to the point. 1.09. What is the ratio of the Exports(as % of merchandise exports) of Honduras in 1982 to that in 1989?
Your answer should be very brief. 0.99. What is the ratio of the Exports(as % of merchandise exports) in Norway in 1982 to that in 1989?
Give a very brief answer. 0.94. What is the ratio of the Exports(as % of merchandise exports) in Uruguay in 1982 to that in 1989?
Offer a very short reply. 1.2. What is the ratio of the Exports(as % of merchandise exports) in Euro area in 1982 to that in 1990?
Your answer should be compact. 1.12. What is the ratio of the Exports(as % of merchandise exports) of Honduras in 1982 to that in 1990?
Provide a succinct answer. 0.96. What is the ratio of the Exports(as % of merchandise exports) of Norway in 1982 to that in 1990?
Make the answer very short. 0.92. What is the ratio of the Exports(as % of merchandise exports) of Uruguay in 1982 to that in 1990?
Make the answer very short. 1.13. What is the ratio of the Exports(as % of merchandise exports) of Euro area in 1983 to that in 1984?
Make the answer very short. 1.01. What is the ratio of the Exports(as % of merchandise exports) in Honduras in 1983 to that in 1984?
Your answer should be compact. 0.96. What is the ratio of the Exports(as % of merchandise exports) in Norway in 1983 to that in 1984?
Give a very brief answer. 1.13. What is the ratio of the Exports(as % of merchandise exports) of Uruguay in 1983 to that in 1984?
Offer a terse response. 1.23. What is the ratio of the Exports(as % of merchandise exports) in Euro area in 1983 to that in 1985?
Keep it short and to the point. 1.04. What is the ratio of the Exports(as % of merchandise exports) of Honduras in 1983 to that in 1985?
Keep it short and to the point. 0.91. What is the ratio of the Exports(as % of merchandise exports) of Norway in 1983 to that in 1985?
Keep it short and to the point. 1.19. What is the ratio of the Exports(as % of merchandise exports) of Uruguay in 1983 to that in 1985?
Provide a short and direct response. 1.2. What is the ratio of the Exports(as % of merchandise exports) in Euro area in 1983 to that in 1988?
Provide a short and direct response. 1.03. What is the ratio of the Exports(as % of merchandise exports) in Honduras in 1983 to that in 1988?
Offer a very short reply. 0.92. What is the ratio of the Exports(as % of merchandise exports) of Norway in 1983 to that in 1988?
Provide a succinct answer. 0.8. What is the ratio of the Exports(as % of merchandise exports) in Uruguay in 1983 to that in 1988?
Ensure brevity in your answer.  1.54. What is the ratio of the Exports(as % of merchandise exports) in Euro area in 1983 to that in 1989?
Your answer should be compact. 1.06. What is the ratio of the Exports(as % of merchandise exports) in Honduras in 1983 to that in 1989?
Make the answer very short. 0.97. What is the ratio of the Exports(as % of merchandise exports) of Uruguay in 1983 to that in 1989?
Your response must be concise. 1.37. What is the ratio of the Exports(as % of merchandise exports) in Euro area in 1983 to that in 1990?
Provide a succinct answer. 1.1. What is the ratio of the Exports(as % of merchandise exports) of Honduras in 1983 to that in 1990?
Your answer should be compact. 0.95. What is the ratio of the Exports(as % of merchandise exports) in Norway in 1983 to that in 1990?
Your answer should be compact. 0.97. What is the ratio of the Exports(as % of merchandise exports) of Uruguay in 1983 to that in 1990?
Make the answer very short. 1.29. What is the ratio of the Exports(as % of merchandise exports) of Euro area in 1984 to that in 1985?
Provide a succinct answer. 1.03. What is the ratio of the Exports(as % of merchandise exports) in Honduras in 1984 to that in 1985?
Your answer should be very brief. 0.95. What is the ratio of the Exports(as % of merchandise exports) in Norway in 1984 to that in 1985?
Offer a terse response. 1.05. What is the ratio of the Exports(as % of merchandise exports) in Uruguay in 1984 to that in 1985?
Your answer should be compact. 0.98. What is the ratio of the Exports(as % of merchandise exports) of Euro area in 1984 to that in 1988?
Keep it short and to the point. 1.02. What is the ratio of the Exports(as % of merchandise exports) in Honduras in 1984 to that in 1988?
Give a very brief answer. 0.96. What is the ratio of the Exports(as % of merchandise exports) in Norway in 1984 to that in 1988?
Ensure brevity in your answer.  0.71. What is the ratio of the Exports(as % of merchandise exports) of Uruguay in 1984 to that in 1988?
Keep it short and to the point. 1.25. What is the ratio of the Exports(as % of merchandise exports) of Euro area in 1984 to that in 1989?
Keep it short and to the point. 1.05. What is the ratio of the Exports(as % of merchandise exports) of Honduras in 1984 to that in 1989?
Offer a very short reply. 1.01. What is the ratio of the Exports(as % of merchandise exports) in Norway in 1984 to that in 1989?
Your answer should be compact. 0.88. What is the ratio of the Exports(as % of merchandise exports) in Uruguay in 1984 to that in 1989?
Provide a succinct answer. 1.11. What is the ratio of the Exports(as % of merchandise exports) in Euro area in 1984 to that in 1990?
Your answer should be very brief. 1.08. What is the ratio of the Exports(as % of merchandise exports) of Norway in 1984 to that in 1990?
Your response must be concise. 0.85. What is the ratio of the Exports(as % of merchandise exports) in Uruguay in 1984 to that in 1990?
Ensure brevity in your answer.  1.05. What is the ratio of the Exports(as % of merchandise exports) in Norway in 1985 to that in 1988?
Your answer should be compact. 0.68. What is the ratio of the Exports(as % of merchandise exports) of Uruguay in 1985 to that in 1988?
Make the answer very short. 1.28. What is the ratio of the Exports(as % of merchandise exports) of Euro area in 1985 to that in 1989?
Your answer should be very brief. 1.02. What is the ratio of the Exports(as % of merchandise exports) in Honduras in 1985 to that in 1989?
Give a very brief answer. 1.06. What is the ratio of the Exports(as % of merchandise exports) of Norway in 1985 to that in 1989?
Your answer should be compact. 0.84. What is the ratio of the Exports(as % of merchandise exports) of Uruguay in 1985 to that in 1989?
Provide a succinct answer. 1.14. What is the ratio of the Exports(as % of merchandise exports) of Euro area in 1985 to that in 1990?
Ensure brevity in your answer.  1.05. What is the ratio of the Exports(as % of merchandise exports) of Honduras in 1985 to that in 1990?
Your answer should be compact. 1.04. What is the ratio of the Exports(as % of merchandise exports) of Norway in 1985 to that in 1990?
Your response must be concise. 0.82. What is the ratio of the Exports(as % of merchandise exports) of Uruguay in 1985 to that in 1990?
Offer a terse response. 1.07. What is the ratio of the Exports(as % of merchandise exports) in Euro area in 1988 to that in 1989?
Make the answer very short. 1.03. What is the ratio of the Exports(as % of merchandise exports) of Honduras in 1988 to that in 1989?
Ensure brevity in your answer.  1.06. What is the ratio of the Exports(as % of merchandise exports) of Norway in 1988 to that in 1989?
Keep it short and to the point. 1.24. What is the ratio of the Exports(as % of merchandise exports) in Uruguay in 1988 to that in 1989?
Ensure brevity in your answer.  0.89. What is the ratio of the Exports(as % of merchandise exports) in Euro area in 1988 to that in 1990?
Your answer should be very brief. 1.06. What is the ratio of the Exports(as % of merchandise exports) of Honduras in 1988 to that in 1990?
Provide a short and direct response. 1.03. What is the ratio of the Exports(as % of merchandise exports) in Norway in 1988 to that in 1990?
Your answer should be compact. 1.21. What is the ratio of the Exports(as % of merchandise exports) of Uruguay in 1988 to that in 1990?
Ensure brevity in your answer.  0.84. What is the ratio of the Exports(as % of merchandise exports) in Euro area in 1989 to that in 1990?
Your answer should be very brief. 1.03. What is the ratio of the Exports(as % of merchandise exports) of Honduras in 1989 to that in 1990?
Offer a very short reply. 0.97. What is the ratio of the Exports(as % of merchandise exports) of Norway in 1989 to that in 1990?
Keep it short and to the point. 0.98. What is the ratio of the Exports(as % of merchandise exports) in Uruguay in 1989 to that in 1990?
Your response must be concise. 0.94. What is the difference between the highest and the second highest Exports(as % of merchandise exports) in Euro area?
Give a very brief answer. 0.29. What is the difference between the highest and the second highest Exports(as % of merchandise exports) of Honduras?
Offer a terse response. 0.65. What is the difference between the highest and the second highest Exports(as % of merchandise exports) of Norway?
Provide a short and direct response. 1.44. What is the difference between the highest and the second highest Exports(as % of merchandise exports) in Uruguay?
Provide a succinct answer. 6.26. What is the difference between the highest and the lowest Exports(as % of merchandise exports) of Euro area?
Provide a succinct answer. 1.29. What is the difference between the highest and the lowest Exports(as % of merchandise exports) of Honduras?
Offer a terse response. 7.36. What is the difference between the highest and the lowest Exports(as % of merchandise exports) of Norway?
Your answer should be very brief. 2.72. What is the difference between the highest and the lowest Exports(as % of merchandise exports) in Uruguay?
Your answer should be very brief. 17.87. 